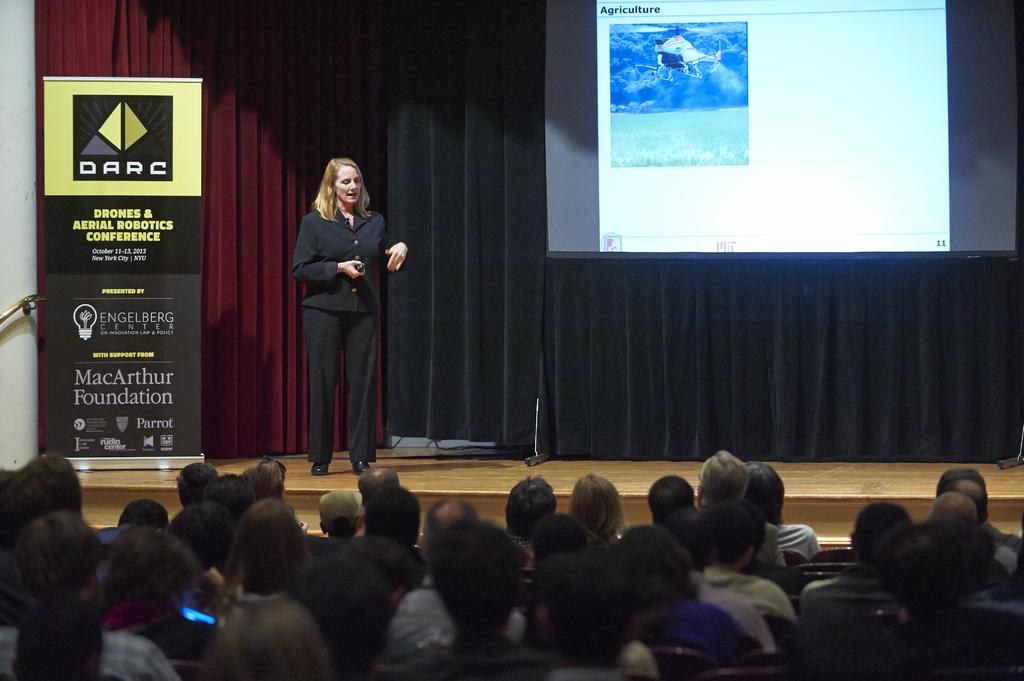What are the people in the image doing? The people in the image are sitting on chairs. What is the woman in the image doing? The woman is standing and talking in the image. What can be seen hanging in the image? There is a banner in the image. What is located behind the people in the image? There is a screen in the background of the image. What is covering the screen in the image? There are curtains associated with the screen. What is being displayed on the screen in the image? An airplane is visible on the screen. What type of wheel is being used by the woman in the image? There is no wheel present in the image; the woman is standing and talking. What kind of beetle can be seen crawling on the banner in the image? There are no beetles present in the image; the banner is hanging without any insects on it. 